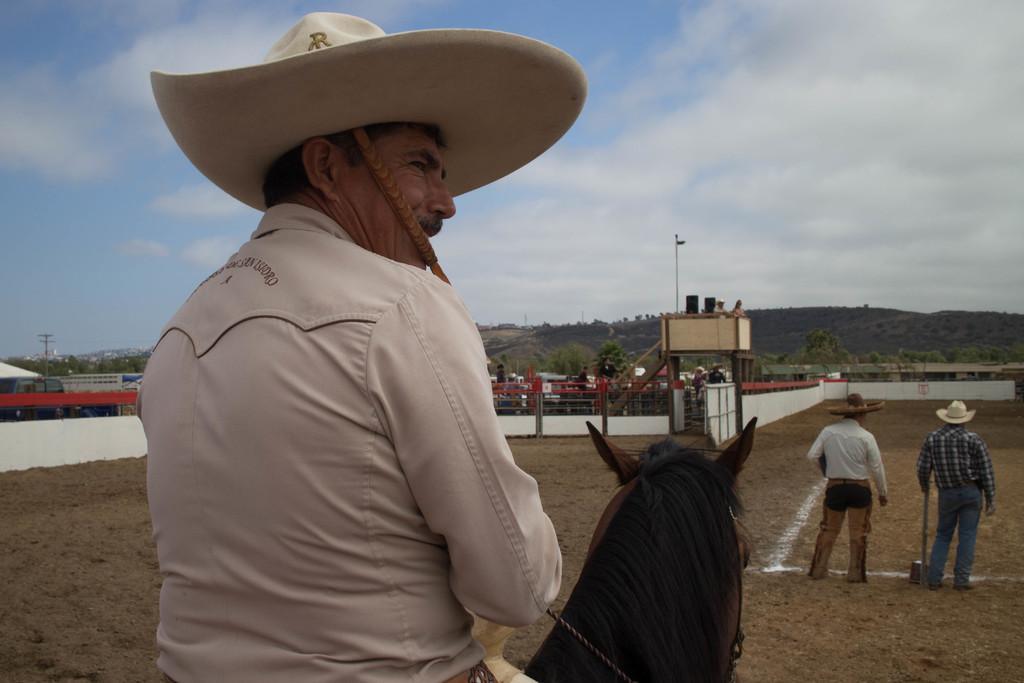Can you describe this image briefly? This is a picture taken in the outdoor, there is a man who is riding the horse. In front of the horse there are two man standing on the field. Background of this people there is a fencing, mountain and a sky with clouds. 